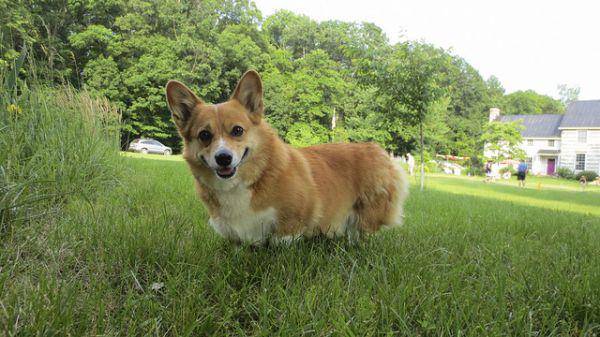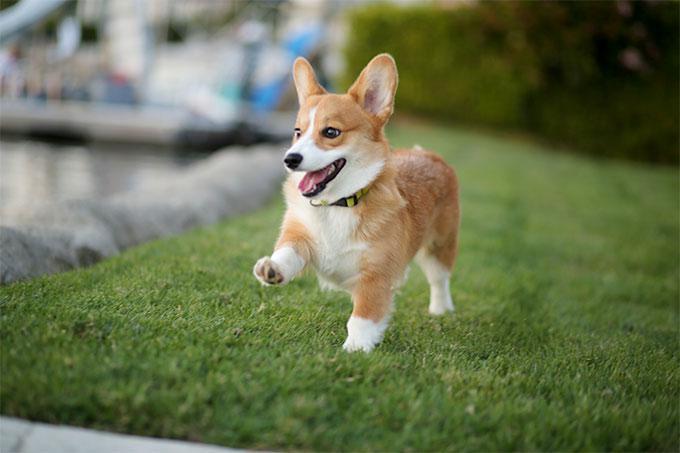The first image is the image on the left, the second image is the image on the right. Given the left and right images, does the statement "The dog in the image on the left is standing in the grass on all four legs." hold true? Answer yes or no. Yes. The first image is the image on the left, the second image is the image on the right. Considering the images on both sides, is "An image shows a corgi dog moving across the grass, with one front paw raised." valid? Answer yes or no. Yes. 